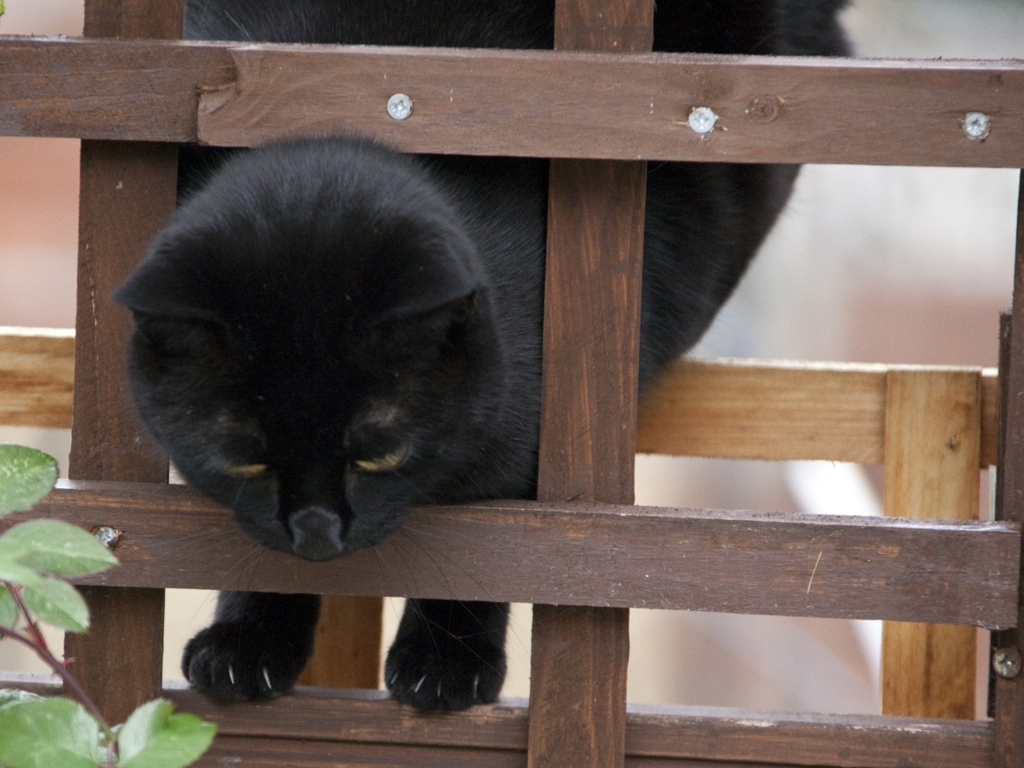What is the overall quality of the image?
A. good
B. excellent
C. average
D. poor
Answer with the option's letter from the given choices directly. The overall quality of the image can be considered average due to several factors such as the lighting being a bit dark, which affects visibility, and the focus which is not entirely sharp. The composition is fairly good, capturing a candid moment of a black cat peeking through a wooden lattice; however, the details are not as clear as they could be. Therefore, the best rating for this image would be option C, average. 